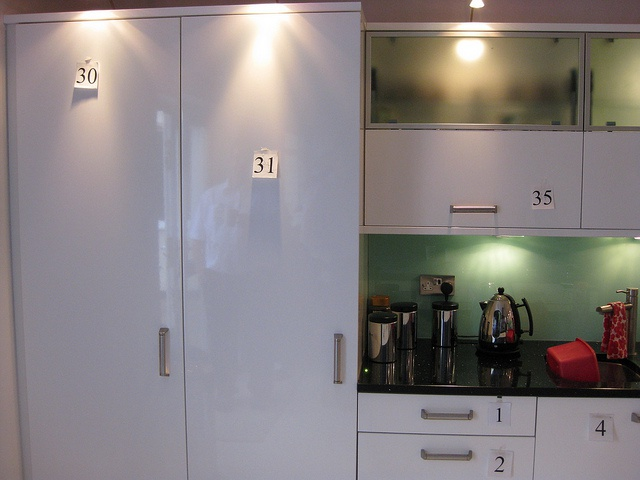Describe the objects in this image and their specific colors. I can see sink in brown, black, tan, and gray tones, cup in brown, black, and gray tones, and cup in brown, black, gray, and darkgray tones in this image. 